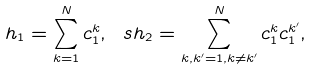<formula> <loc_0><loc_0><loc_500><loc_500>h _ { 1 } = \sum _ { k = 1 } ^ { N } c ^ { k } _ { 1 } , \ s h _ { 2 } = \sum _ { k , k ^ { \prime } = 1 , k \neq k ^ { \prime } } ^ { N } c ^ { k } _ { 1 } c ^ { k ^ { \prime } } _ { 1 } ,</formula> 